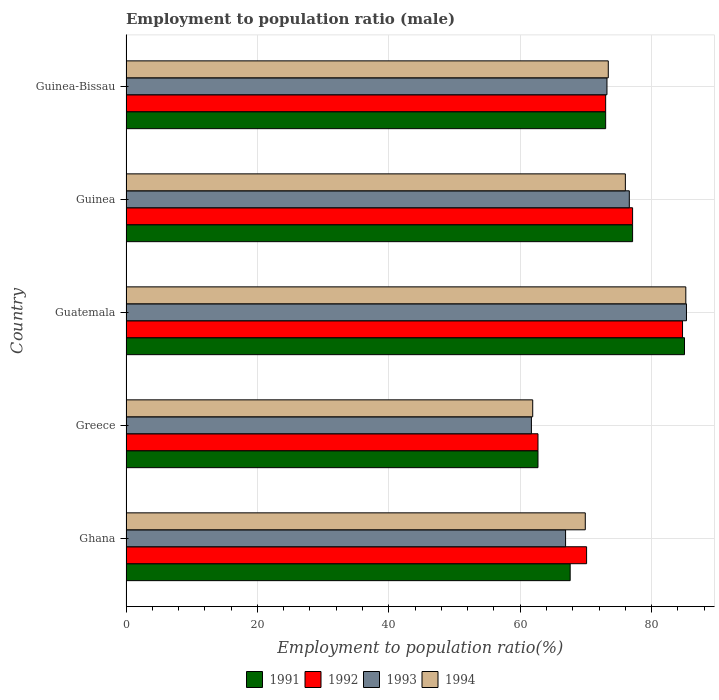How many different coloured bars are there?
Make the answer very short. 4. How many groups of bars are there?
Your response must be concise. 5. Are the number of bars on each tick of the Y-axis equal?
Ensure brevity in your answer.  Yes. How many bars are there on the 5th tick from the bottom?
Your answer should be compact. 4. In how many cases, is the number of bars for a given country not equal to the number of legend labels?
Your answer should be very brief. 0. What is the employment to population ratio in 1992 in Guinea?
Your answer should be compact. 77.1. Across all countries, what is the maximum employment to population ratio in 1994?
Ensure brevity in your answer.  85.2. Across all countries, what is the minimum employment to population ratio in 1994?
Keep it short and to the point. 61.9. In which country was the employment to population ratio in 1994 maximum?
Your response must be concise. Guatemala. What is the total employment to population ratio in 1991 in the graph?
Ensure brevity in your answer.  365.4. What is the difference between the employment to population ratio in 1991 in Greece and that in Guatemala?
Keep it short and to the point. -22.3. What is the difference between the employment to population ratio in 1991 in Guinea and the employment to population ratio in 1993 in Guinea-Bissau?
Keep it short and to the point. 3.9. What is the average employment to population ratio in 1993 per country?
Make the answer very short. 72.74. What is the difference between the employment to population ratio in 1993 and employment to population ratio in 1994 in Guatemala?
Your answer should be very brief. 0.1. In how many countries, is the employment to population ratio in 1992 greater than 36 %?
Ensure brevity in your answer.  5. What is the ratio of the employment to population ratio in 1992 in Ghana to that in Guinea?
Provide a succinct answer. 0.91. Is the difference between the employment to population ratio in 1993 in Guatemala and Guinea-Bissau greater than the difference between the employment to population ratio in 1994 in Guatemala and Guinea-Bissau?
Give a very brief answer. Yes. What is the difference between the highest and the second highest employment to population ratio in 1992?
Give a very brief answer. 7.6. What is the difference between the highest and the lowest employment to population ratio in 1991?
Provide a succinct answer. 22.3. What does the 4th bar from the bottom in Greece represents?
Your answer should be very brief. 1994. How many bars are there?
Offer a terse response. 20. Are all the bars in the graph horizontal?
Offer a very short reply. Yes. How many countries are there in the graph?
Offer a very short reply. 5. What is the difference between two consecutive major ticks on the X-axis?
Make the answer very short. 20. Are the values on the major ticks of X-axis written in scientific E-notation?
Your response must be concise. No. Where does the legend appear in the graph?
Provide a succinct answer. Bottom center. What is the title of the graph?
Provide a succinct answer. Employment to population ratio (male). What is the label or title of the X-axis?
Provide a succinct answer. Employment to population ratio(%). What is the Employment to population ratio(%) of 1991 in Ghana?
Provide a succinct answer. 67.6. What is the Employment to population ratio(%) of 1992 in Ghana?
Your response must be concise. 70.1. What is the Employment to population ratio(%) in 1993 in Ghana?
Give a very brief answer. 66.9. What is the Employment to population ratio(%) of 1994 in Ghana?
Provide a short and direct response. 69.9. What is the Employment to population ratio(%) in 1991 in Greece?
Offer a very short reply. 62.7. What is the Employment to population ratio(%) of 1992 in Greece?
Offer a very short reply. 62.7. What is the Employment to population ratio(%) in 1993 in Greece?
Your answer should be compact. 61.7. What is the Employment to population ratio(%) of 1994 in Greece?
Your response must be concise. 61.9. What is the Employment to population ratio(%) of 1992 in Guatemala?
Give a very brief answer. 84.7. What is the Employment to population ratio(%) in 1993 in Guatemala?
Your answer should be very brief. 85.3. What is the Employment to population ratio(%) in 1994 in Guatemala?
Ensure brevity in your answer.  85.2. What is the Employment to population ratio(%) of 1991 in Guinea?
Keep it short and to the point. 77.1. What is the Employment to population ratio(%) of 1992 in Guinea?
Make the answer very short. 77.1. What is the Employment to population ratio(%) in 1993 in Guinea?
Your answer should be very brief. 76.6. What is the Employment to population ratio(%) in 1994 in Guinea?
Your response must be concise. 76. What is the Employment to population ratio(%) in 1992 in Guinea-Bissau?
Offer a terse response. 73. What is the Employment to population ratio(%) of 1993 in Guinea-Bissau?
Ensure brevity in your answer.  73.2. What is the Employment to population ratio(%) of 1994 in Guinea-Bissau?
Make the answer very short. 73.4. Across all countries, what is the maximum Employment to population ratio(%) of 1992?
Give a very brief answer. 84.7. Across all countries, what is the maximum Employment to population ratio(%) in 1993?
Your answer should be very brief. 85.3. Across all countries, what is the maximum Employment to population ratio(%) of 1994?
Provide a succinct answer. 85.2. Across all countries, what is the minimum Employment to population ratio(%) in 1991?
Offer a very short reply. 62.7. Across all countries, what is the minimum Employment to population ratio(%) in 1992?
Your response must be concise. 62.7. Across all countries, what is the minimum Employment to population ratio(%) in 1993?
Your answer should be very brief. 61.7. Across all countries, what is the minimum Employment to population ratio(%) in 1994?
Offer a terse response. 61.9. What is the total Employment to population ratio(%) in 1991 in the graph?
Offer a terse response. 365.4. What is the total Employment to population ratio(%) in 1992 in the graph?
Offer a terse response. 367.6. What is the total Employment to population ratio(%) of 1993 in the graph?
Offer a very short reply. 363.7. What is the total Employment to population ratio(%) of 1994 in the graph?
Provide a succinct answer. 366.4. What is the difference between the Employment to population ratio(%) of 1993 in Ghana and that in Greece?
Make the answer very short. 5.2. What is the difference between the Employment to population ratio(%) in 1994 in Ghana and that in Greece?
Make the answer very short. 8. What is the difference between the Employment to population ratio(%) of 1991 in Ghana and that in Guatemala?
Your response must be concise. -17.4. What is the difference between the Employment to population ratio(%) of 1992 in Ghana and that in Guatemala?
Provide a short and direct response. -14.6. What is the difference between the Employment to population ratio(%) of 1993 in Ghana and that in Guatemala?
Keep it short and to the point. -18.4. What is the difference between the Employment to population ratio(%) in 1994 in Ghana and that in Guatemala?
Keep it short and to the point. -15.3. What is the difference between the Employment to population ratio(%) in 1994 in Ghana and that in Guinea?
Offer a terse response. -6.1. What is the difference between the Employment to population ratio(%) of 1991 in Ghana and that in Guinea-Bissau?
Your answer should be compact. -5.4. What is the difference between the Employment to population ratio(%) of 1992 in Ghana and that in Guinea-Bissau?
Offer a terse response. -2.9. What is the difference between the Employment to population ratio(%) of 1994 in Ghana and that in Guinea-Bissau?
Provide a short and direct response. -3.5. What is the difference between the Employment to population ratio(%) in 1991 in Greece and that in Guatemala?
Your answer should be compact. -22.3. What is the difference between the Employment to population ratio(%) of 1992 in Greece and that in Guatemala?
Your response must be concise. -22. What is the difference between the Employment to population ratio(%) of 1993 in Greece and that in Guatemala?
Your response must be concise. -23.6. What is the difference between the Employment to population ratio(%) in 1994 in Greece and that in Guatemala?
Your response must be concise. -23.3. What is the difference between the Employment to population ratio(%) in 1991 in Greece and that in Guinea?
Provide a succinct answer. -14.4. What is the difference between the Employment to population ratio(%) in 1992 in Greece and that in Guinea?
Your answer should be very brief. -14.4. What is the difference between the Employment to population ratio(%) of 1993 in Greece and that in Guinea?
Provide a succinct answer. -14.9. What is the difference between the Employment to population ratio(%) in 1994 in Greece and that in Guinea?
Your response must be concise. -14.1. What is the difference between the Employment to population ratio(%) of 1991 in Greece and that in Guinea-Bissau?
Provide a succinct answer. -10.3. What is the difference between the Employment to population ratio(%) of 1992 in Greece and that in Guinea-Bissau?
Keep it short and to the point. -10.3. What is the difference between the Employment to population ratio(%) of 1991 in Guatemala and that in Guinea-Bissau?
Give a very brief answer. 12. What is the difference between the Employment to population ratio(%) in 1991 in Guinea and that in Guinea-Bissau?
Offer a terse response. 4.1. What is the difference between the Employment to population ratio(%) of 1994 in Guinea and that in Guinea-Bissau?
Give a very brief answer. 2.6. What is the difference between the Employment to population ratio(%) in 1991 in Ghana and the Employment to population ratio(%) in 1992 in Greece?
Your answer should be very brief. 4.9. What is the difference between the Employment to population ratio(%) of 1991 in Ghana and the Employment to population ratio(%) of 1993 in Greece?
Your response must be concise. 5.9. What is the difference between the Employment to population ratio(%) of 1992 in Ghana and the Employment to population ratio(%) of 1994 in Greece?
Your answer should be very brief. 8.2. What is the difference between the Employment to population ratio(%) of 1991 in Ghana and the Employment to population ratio(%) of 1992 in Guatemala?
Offer a terse response. -17.1. What is the difference between the Employment to population ratio(%) of 1991 in Ghana and the Employment to population ratio(%) of 1993 in Guatemala?
Keep it short and to the point. -17.7. What is the difference between the Employment to population ratio(%) of 1991 in Ghana and the Employment to population ratio(%) of 1994 in Guatemala?
Offer a terse response. -17.6. What is the difference between the Employment to population ratio(%) of 1992 in Ghana and the Employment to population ratio(%) of 1993 in Guatemala?
Give a very brief answer. -15.2. What is the difference between the Employment to population ratio(%) of 1992 in Ghana and the Employment to population ratio(%) of 1994 in Guatemala?
Your response must be concise. -15.1. What is the difference between the Employment to population ratio(%) of 1993 in Ghana and the Employment to population ratio(%) of 1994 in Guatemala?
Keep it short and to the point. -18.3. What is the difference between the Employment to population ratio(%) of 1991 in Ghana and the Employment to population ratio(%) of 1994 in Guinea?
Your answer should be very brief. -8.4. What is the difference between the Employment to population ratio(%) of 1992 in Ghana and the Employment to population ratio(%) of 1993 in Guinea?
Keep it short and to the point. -6.5. What is the difference between the Employment to population ratio(%) of 1992 in Ghana and the Employment to population ratio(%) of 1994 in Guinea?
Offer a very short reply. -5.9. What is the difference between the Employment to population ratio(%) of 1993 in Ghana and the Employment to population ratio(%) of 1994 in Guinea?
Offer a very short reply. -9.1. What is the difference between the Employment to population ratio(%) of 1992 in Ghana and the Employment to population ratio(%) of 1993 in Guinea-Bissau?
Make the answer very short. -3.1. What is the difference between the Employment to population ratio(%) in 1993 in Ghana and the Employment to population ratio(%) in 1994 in Guinea-Bissau?
Ensure brevity in your answer.  -6.5. What is the difference between the Employment to population ratio(%) of 1991 in Greece and the Employment to population ratio(%) of 1993 in Guatemala?
Your answer should be compact. -22.6. What is the difference between the Employment to population ratio(%) of 1991 in Greece and the Employment to population ratio(%) of 1994 in Guatemala?
Your answer should be very brief. -22.5. What is the difference between the Employment to population ratio(%) of 1992 in Greece and the Employment to population ratio(%) of 1993 in Guatemala?
Provide a short and direct response. -22.6. What is the difference between the Employment to population ratio(%) of 1992 in Greece and the Employment to population ratio(%) of 1994 in Guatemala?
Provide a short and direct response. -22.5. What is the difference between the Employment to population ratio(%) in 1993 in Greece and the Employment to population ratio(%) in 1994 in Guatemala?
Make the answer very short. -23.5. What is the difference between the Employment to population ratio(%) of 1991 in Greece and the Employment to population ratio(%) of 1992 in Guinea?
Your response must be concise. -14.4. What is the difference between the Employment to population ratio(%) in 1991 in Greece and the Employment to population ratio(%) in 1993 in Guinea?
Your answer should be compact. -13.9. What is the difference between the Employment to population ratio(%) in 1991 in Greece and the Employment to population ratio(%) in 1994 in Guinea?
Ensure brevity in your answer.  -13.3. What is the difference between the Employment to population ratio(%) in 1992 in Greece and the Employment to population ratio(%) in 1994 in Guinea?
Offer a very short reply. -13.3. What is the difference between the Employment to population ratio(%) in 1993 in Greece and the Employment to population ratio(%) in 1994 in Guinea?
Offer a terse response. -14.3. What is the difference between the Employment to population ratio(%) in 1991 in Greece and the Employment to population ratio(%) in 1994 in Guinea-Bissau?
Ensure brevity in your answer.  -10.7. What is the difference between the Employment to population ratio(%) in 1992 in Greece and the Employment to population ratio(%) in 1993 in Guinea-Bissau?
Provide a succinct answer. -10.5. What is the difference between the Employment to population ratio(%) in 1992 in Greece and the Employment to population ratio(%) in 1994 in Guinea-Bissau?
Provide a succinct answer. -10.7. What is the difference between the Employment to population ratio(%) in 1993 in Greece and the Employment to population ratio(%) in 1994 in Guinea-Bissau?
Your response must be concise. -11.7. What is the difference between the Employment to population ratio(%) in 1991 in Guatemala and the Employment to population ratio(%) in 1993 in Guinea?
Your response must be concise. 8.4. What is the difference between the Employment to population ratio(%) in 1992 in Guatemala and the Employment to population ratio(%) in 1994 in Guinea?
Keep it short and to the point. 8.7. What is the difference between the Employment to population ratio(%) of 1993 in Guatemala and the Employment to population ratio(%) of 1994 in Guinea?
Offer a terse response. 9.3. What is the difference between the Employment to population ratio(%) of 1991 in Guatemala and the Employment to population ratio(%) of 1993 in Guinea-Bissau?
Make the answer very short. 11.8. What is the difference between the Employment to population ratio(%) in 1991 in Guatemala and the Employment to population ratio(%) in 1994 in Guinea-Bissau?
Provide a succinct answer. 11.6. What is the difference between the Employment to population ratio(%) in 1993 in Guatemala and the Employment to population ratio(%) in 1994 in Guinea-Bissau?
Make the answer very short. 11.9. What is the difference between the Employment to population ratio(%) in 1991 in Guinea and the Employment to population ratio(%) in 1992 in Guinea-Bissau?
Your response must be concise. 4.1. What is the difference between the Employment to population ratio(%) in 1991 in Guinea and the Employment to population ratio(%) in 1993 in Guinea-Bissau?
Provide a short and direct response. 3.9. What is the difference between the Employment to population ratio(%) of 1992 in Guinea and the Employment to population ratio(%) of 1993 in Guinea-Bissau?
Your answer should be very brief. 3.9. What is the difference between the Employment to population ratio(%) of 1992 in Guinea and the Employment to population ratio(%) of 1994 in Guinea-Bissau?
Your response must be concise. 3.7. What is the difference between the Employment to population ratio(%) in 1993 in Guinea and the Employment to population ratio(%) in 1994 in Guinea-Bissau?
Keep it short and to the point. 3.2. What is the average Employment to population ratio(%) in 1991 per country?
Offer a terse response. 73.08. What is the average Employment to population ratio(%) of 1992 per country?
Your answer should be compact. 73.52. What is the average Employment to population ratio(%) of 1993 per country?
Your response must be concise. 72.74. What is the average Employment to population ratio(%) of 1994 per country?
Make the answer very short. 73.28. What is the difference between the Employment to population ratio(%) of 1991 and Employment to population ratio(%) of 1992 in Ghana?
Offer a very short reply. -2.5. What is the difference between the Employment to population ratio(%) in 1992 and Employment to population ratio(%) in 1993 in Ghana?
Provide a succinct answer. 3.2. What is the difference between the Employment to population ratio(%) in 1991 and Employment to population ratio(%) in 1993 in Greece?
Ensure brevity in your answer.  1. What is the difference between the Employment to population ratio(%) in 1991 and Employment to population ratio(%) in 1994 in Greece?
Keep it short and to the point. 0.8. What is the difference between the Employment to population ratio(%) of 1992 and Employment to population ratio(%) of 1994 in Greece?
Offer a terse response. 0.8. What is the difference between the Employment to population ratio(%) of 1993 and Employment to population ratio(%) of 1994 in Guatemala?
Make the answer very short. 0.1. What is the difference between the Employment to population ratio(%) in 1991 and Employment to population ratio(%) in 1993 in Guinea?
Keep it short and to the point. 0.5. What is the difference between the Employment to population ratio(%) in 1992 and Employment to population ratio(%) in 1993 in Guinea?
Offer a terse response. 0.5. What is the difference between the Employment to population ratio(%) of 1992 and Employment to population ratio(%) of 1994 in Guinea?
Offer a very short reply. 1.1. What is the difference between the Employment to population ratio(%) of 1991 and Employment to population ratio(%) of 1992 in Guinea-Bissau?
Offer a very short reply. 0. What is the difference between the Employment to population ratio(%) of 1991 and Employment to population ratio(%) of 1993 in Guinea-Bissau?
Provide a short and direct response. -0.2. What is the difference between the Employment to population ratio(%) of 1992 and Employment to population ratio(%) of 1993 in Guinea-Bissau?
Ensure brevity in your answer.  -0.2. What is the difference between the Employment to population ratio(%) of 1992 and Employment to population ratio(%) of 1994 in Guinea-Bissau?
Your answer should be compact. -0.4. What is the ratio of the Employment to population ratio(%) of 1991 in Ghana to that in Greece?
Your response must be concise. 1.08. What is the ratio of the Employment to population ratio(%) in 1992 in Ghana to that in Greece?
Keep it short and to the point. 1.12. What is the ratio of the Employment to population ratio(%) of 1993 in Ghana to that in Greece?
Your response must be concise. 1.08. What is the ratio of the Employment to population ratio(%) of 1994 in Ghana to that in Greece?
Provide a succinct answer. 1.13. What is the ratio of the Employment to population ratio(%) in 1991 in Ghana to that in Guatemala?
Offer a very short reply. 0.8. What is the ratio of the Employment to population ratio(%) in 1992 in Ghana to that in Guatemala?
Ensure brevity in your answer.  0.83. What is the ratio of the Employment to population ratio(%) of 1993 in Ghana to that in Guatemala?
Offer a very short reply. 0.78. What is the ratio of the Employment to population ratio(%) in 1994 in Ghana to that in Guatemala?
Provide a succinct answer. 0.82. What is the ratio of the Employment to population ratio(%) in 1991 in Ghana to that in Guinea?
Your answer should be very brief. 0.88. What is the ratio of the Employment to population ratio(%) in 1992 in Ghana to that in Guinea?
Your answer should be very brief. 0.91. What is the ratio of the Employment to population ratio(%) of 1993 in Ghana to that in Guinea?
Offer a terse response. 0.87. What is the ratio of the Employment to population ratio(%) of 1994 in Ghana to that in Guinea?
Provide a succinct answer. 0.92. What is the ratio of the Employment to population ratio(%) in 1991 in Ghana to that in Guinea-Bissau?
Your answer should be compact. 0.93. What is the ratio of the Employment to population ratio(%) of 1992 in Ghana to that in Guinea-Bissau?
Keep it short and to the point. 0.96. What is the ratio of the Employment to population ratio(%) of 1993 in Ghana to that in Guinea-Bissau?
Offer a terse response. 0.91. What is the ratio of the Employment to population ratio(%) of 1994 in Ghana to that in Guinea-Bissau?
Offer a very short reply. 0.95. What is the ratio of the Employment to population ratio(%) in 1991 in Greece to that in Guatemala?
Offer a terse response. 0.74. What is the ratio of the Employment to population ratio(%) of 1992 in Greece to that in Guatemala?
Keep it short and to the point. 0.74. What is the ratio of the Employment to population ratio(%) of 1993 in Greece to that in Guatemala?
Offer a very short reply. 0.72. What is the ratio of the Employment to population ratio(%) of 1994 in Greece to that in Guatemala?
Your answer should be compact. 0.73. What is the ratio of the Employment to population ratio(%) in 1991 in Greece to that in Guinea?
Your answer should be very brief. 0.81. What is the ratio of the Employment to population ratio(%) in 1992 in Greece to that in Guinea?
Ensure brevity in your answer.  0.81. What is the ratio of the Employment to population ratio(%) in 1993 in Greece to that in Guinea?
Ensure brevity in your answer.  0.81. What is the ratio of the Employment to population ratio(%) of 1994 in Greece to that in Guinea?
Keep it short and to the point. 0.81. What is the ratio of the Employment to population ratio(%) of 1991 in Greece to that in Guinea-Bissau?
Your answer should be compact. 0.86. What is the ratio of the Employment to population ratio(%) of 1992 in Greece to that in Guinea-Bissau?
Offer a terse response. 0.86. What is the ratio of the Employment to population ratio(%) in 1993 in Greece to that in Guinea-Bissau?
Your answer should be compact. 0.84. What is the ratio of the Employment to population ratio(%) of 1994 in Greece to that in Guinea-Bissau?
Your response must be concise. 0.84. What is the ratio of the Employment to population ratio(%) of 1991 in Guatemala to that in Guinea?
Ensure brevity in your answer.  1.1. What is the ratio of the Employment to population ratio(%) in 1992 in Guatemala to that in Guinea?
Your response must be concise. 1.1. What is the ratio of the Employment to population ratio(%) of 1993 in Guatemala to that in Guinea?
Keep it short and to the point. 1.11. What is the ratio of the Employment to population ratio(%) of 1994 in Guatemala to that in Guinea?
Your response must be concise. 1.12. What is the ratio of the Employment to population ratio(%) of 1991 in Guatemala to that in Guinea-Bissau?
Offer a terse response. 1.16. What is the ratio of the Employment to population ratio(%) in 1992 in Guatemala to that in Guinea-Bissau?
Your answer should be very brief. 1.16. What is the ratio of the Employment to population ratio(%) of 1993 in Guatemala to that in Guinea-Bissau?
Provide a succinct answer. 1.17. What is the ratio of the Employment to population ratio(%) of 1994 in Guatemala to that in Guinea-Bissau?
Keep it short and to the point. 1.16. What is the ratio of the Employment to population ratio(%) of 1991 in Guinea to that in Guinea-Bissau?
Offer a terse response. 1.06. What is the ratio of the Employment to population ratio(%) of 1992 in Guinea to that in Guinea-Bissau?
Your response must be concise. 1.06. What is the ratio of the Employment to population ratio(%) in 1993 in Guinea to that in Guinea-Bissau?
Provide a succinct answer. 1.05. What is the ratio of the Employment to population ratio(%) of 1994 in Guinea to that in Guinea-Bissau?
Offer a very short reply. 1.04. What is the difference between the highest and the second highest Employment to population ratio(%) in 1991?
Ensure brevity in your answer.  7.9. What is the difference between the highest and the second highest Employment to population ratio(%) of 1993?
Give a very brief answer. 8.7. What is the difference between the highest and the second highest Employment to population ratio(%) in 1994?
Give a very brief answer. 9.2. What is the difference between the highest and the lowest Employment to population ratio(%) in 1991?
Make the answer very short. 22.3. What is the difference between the highest and the lowest Employment to population ratio(%) in 1993?
Provide a short and direct response. 23.6. What is the difference between the highest and the lowest Employment to population ratio(%) of 1994?
Give a very brief answer. 23.3. 